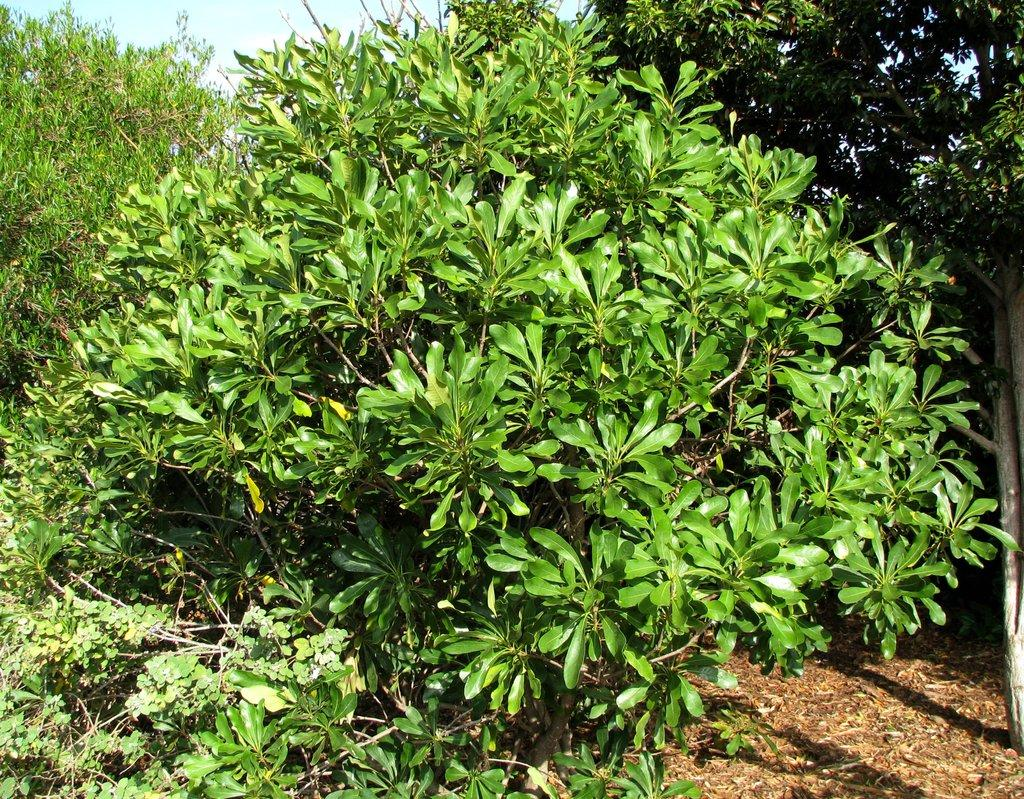What type of vegetation is present in the image? There are green trees in the image. What part of the natural environment can be seen in the background of the image? The sky is visible in the background of the image. What type of property does the fireman own in the image? There is no fireman or property present in the image; it only features green trees and the sky. 